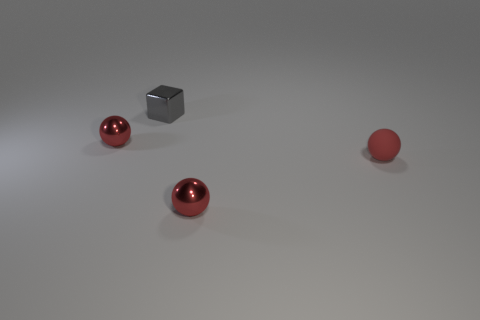Is the matte thing the same size as the gray metal thing?
Make the answer very short. Yes. How many red things are the same size as the gray block?
Provide a succinct answer. 3. Do the ball that is in front of the small red rubber ball and the small thing that is to the left of the small gray metal cube have the same material?
Your answer should be compact. Yes. Is there any other thing that is the same shape as the matte object?
Your response must be concise. Yes. What is the color of the small matte sphere?
Keep it short and to the point. Red. How many red shiny things have the same shape as the small rubber thing?
Give a very brief answer. 2. What is the color of the rubber thing that is the same size as the gray block?
Provide a short and direct response. Red. Are there any gray rubber blocks?
Your response must be concise. No. What shape is the red metal thing that is to the left of the small gray thing?
Give a very brief answer. Sphere. What number of objects are on the left side of the matte sphere and in front of the block?
Keep it short and to the point. 2. 